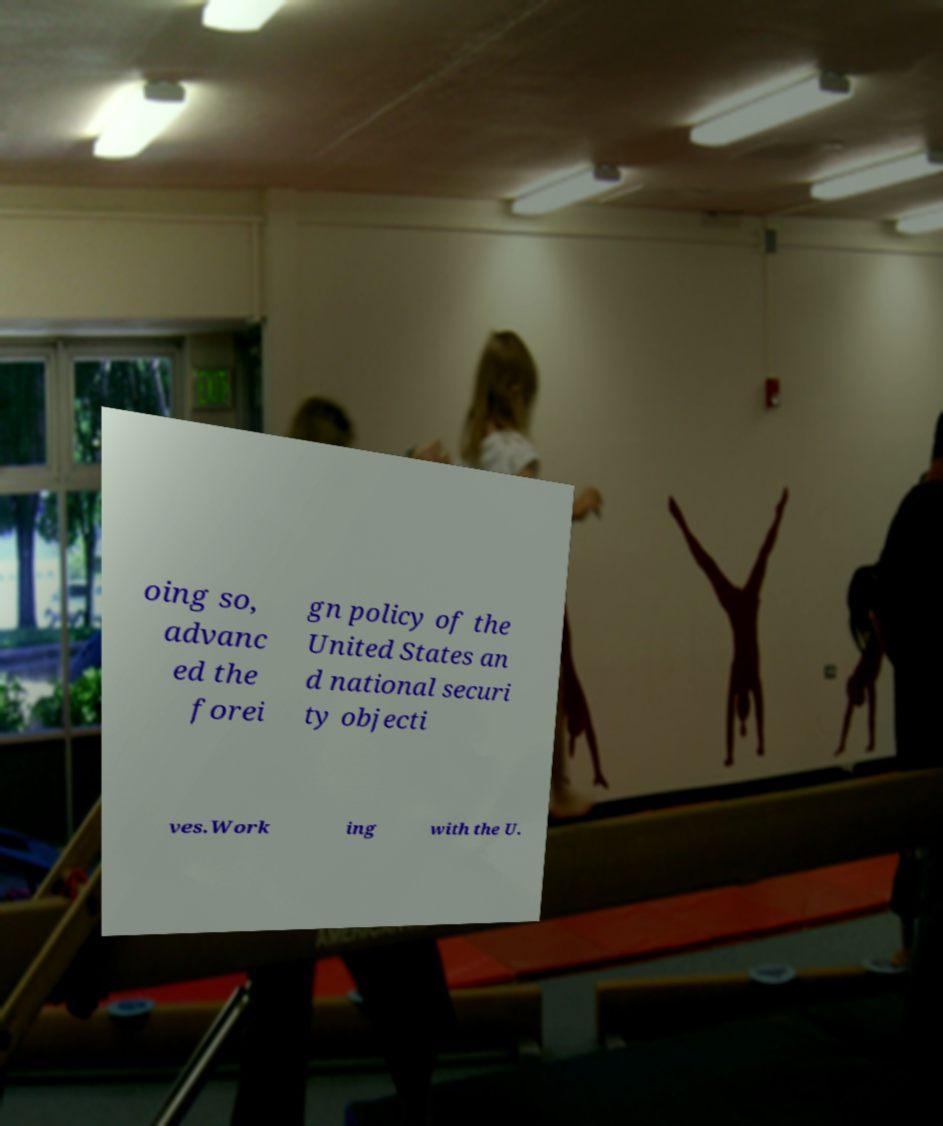Please identify and transcribe the text found in this image. oing so, advanc ed the forei gn policy of the United States an d national securi ty objecti ves.Work ing with the U. 